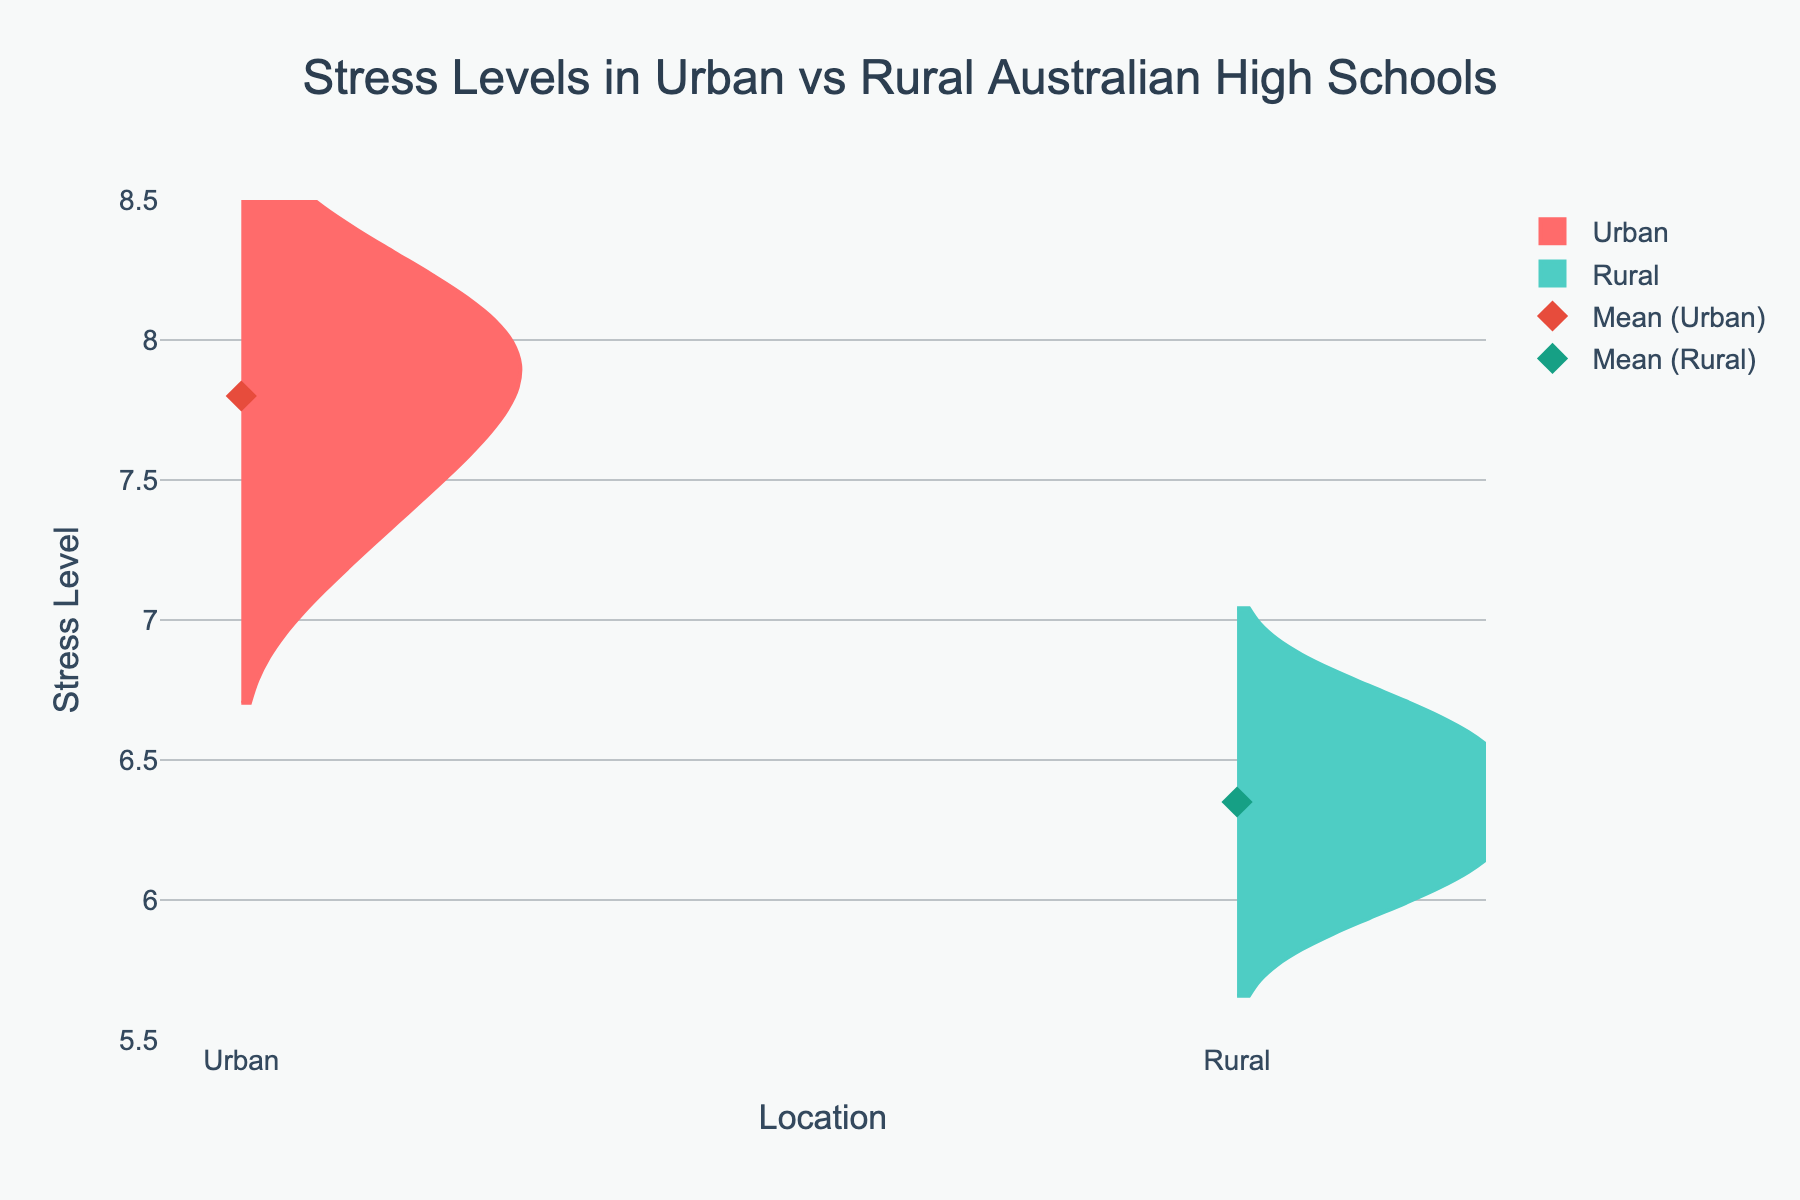what is the title of the figure? The title is given at the top of the figure, written with a larger font size and centered.
Answer: Stress Levels in Urban vs Rural Australian High Schools what are the two locations compared in the figure? The two locations are represented by the different fill colors of the violin plots, shown on the x-axis.
Answer: Urban and Rural what color represents stress levels in urban high schools? The color for urban high schools is visually distinct and warmer in tone, represented on the violin plot.
Answer: Red (or a shade close to red) which location has the highest mean stress level? The mean stress level is indicated by diamond markers on the violin plots. By comparing their vertical positions, we can see which is higher.
Answer: Urban what is the approximate range of stress levels in rural high schools? By observing the length of the violin plot for rural high schools, you can determine the minimum and maximum stress levels.
Answer: 6.0 to 6.7 how do the distributions of stress levels differ between urban and rural high schools? Compare the shapes and spread of the two violin plots to see the variability and concentration of stress levels in each location.
Answer: Urban has a higher mean and a slightly wider spread which school likely has the highest individual stress level data point? The highest individual stress level is represented by the topmost point within the urban violin plot.
Answer: Perth Secondary how does the median stress level in urban high schools compare to the median in rural high schools? Medians can be estimated by identifying the point where each violin plot is the widest and comparing these points.
Answer: Urban median is higher than rural median is there any overlap in the stress levels between the two locations? By looking at the vertical extent of both violin plots, one can determine if there are common values in both distributions.
Answer: Yes if you were to add a secondary title to this plot, what could it be? A secondary title might clarify additional context, such as the sample size or the method of data collection.
Answer: Analysis of Stress Levels Among Australian High School Students 